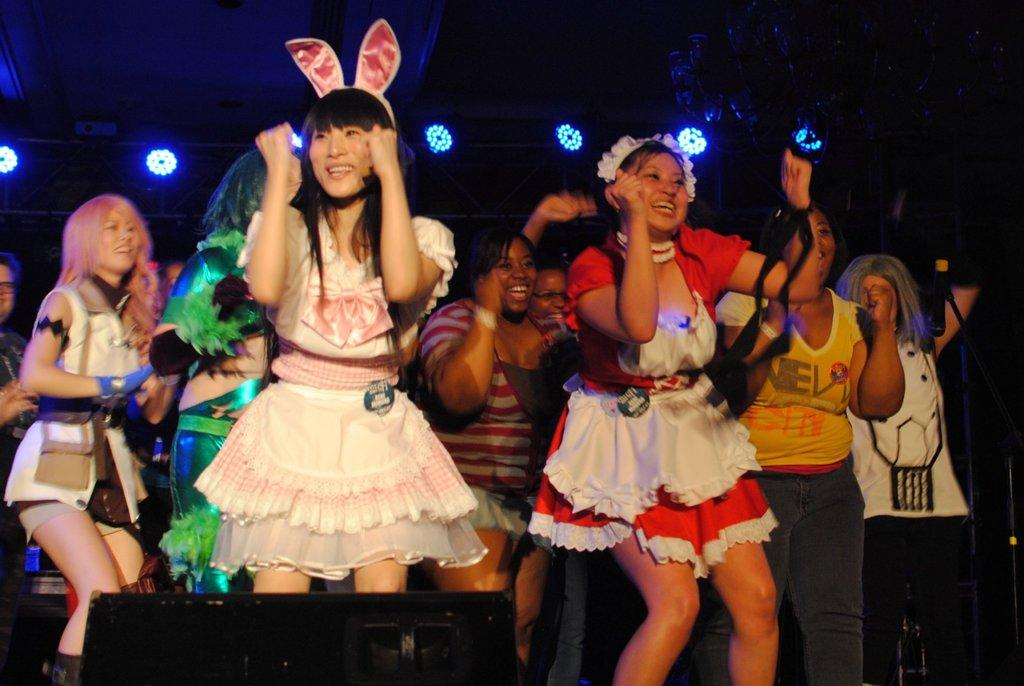What is happening with the groups of people in the image? The people are in fancy dress and dancing on a path. What type of clothing are the people wearing? The people are wearing fancy dress. Where are the people dancing in the image? The people are dancing on a path. What can be seen in the background of the image? There is a dark background in the image. What is providing illumination in the image? Lights are present in the image. What type of debt is being discussed by the people in the image? There is no indication in the image that the people are discussing debt; they are dancing in fancy dress. Where is the faucet located in the image? There is no faucet present in the image. 